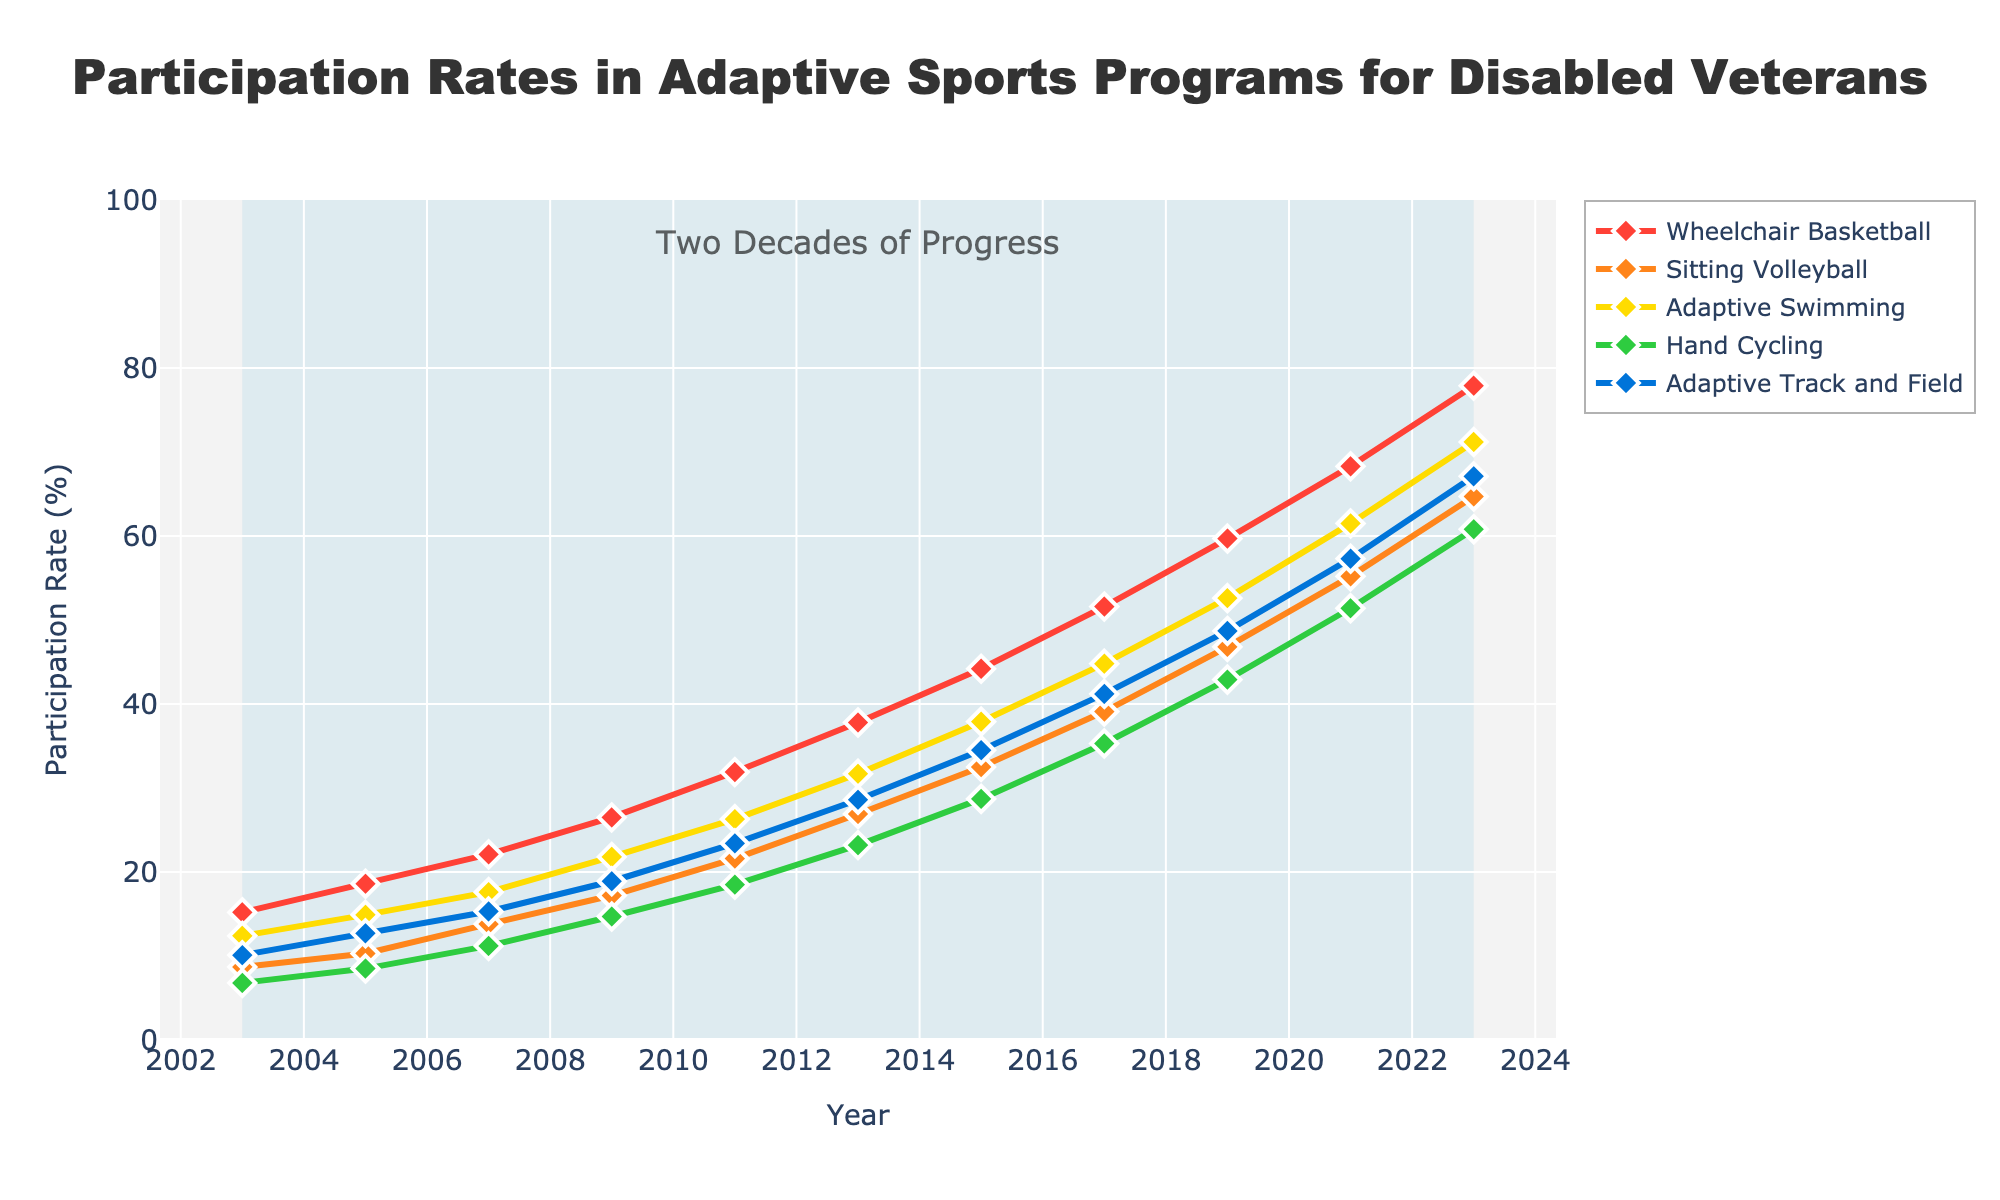Which adaptive sport had the highest participation rate in 2023? By visually inspecting the line chart, it can be seen that at the year 2023, "Wheelchair Basketball" reaches the highest point compared to other sports.
Answer: Wheelchair Basketball Which sport had the lowest initial participation rate in 2003? Looking at the beginning year 2003, "Hand Cycling" has the lowest starting point on the chart.
Answer: Hand Cycling What is the total increase in participation for Adaptive Swimming from 2003 to 2023? For 2003, Adaptive Swimming was at 12.4%. For 2023, it was at 71.2%. The increase is calculated as 71.2 - 12.4 = 58.8%.
Answer: 58.8% How does the participation rate of Sitting Volleyball in 2015 compare to that of Hand Cycling in 2011? For Sitting Volleyball in 2015, the rate was 32.5%. For Hand Cycling in 2011, the rate was 18.5%. Sitting Volleyball in 2015 had a higher participation rate.
Answer: Higher Between which consecutive years did Adaptive Track and Field see the greatest increase in participation rates? By examining the chart for Adaptive Track and Field, the most significant increase appears between 2019 (48.7%) and 2021 (57.3%). The difference is 57.3 - 48.7 = 8.6%.
Answer: 2019 to 2021 What was the average participation rate for Sitting Volleyball over the two decades? Adding the participation rates of Sitting Volleyball from 2003 to 2023 gives 8.7 + 10.3 + 13.8 + 17.2 + 21.6 + 26.9 + 32.5 + 39.1 + 46.8 + 55.2 + 64.7 = 336.8. Dividing by the number of years (11) gives 336.8 ÷ 11.
Answer: 30.6% Which sport showed a consistent trend without a decrease in participation rate over the years? Inspecting the trend lines for each sport, "Wheelchair Basketball" shows a consistent increase year after year without any decrease.
Answer: Wheelchair Basketball What is the difference in participation rates between the most and least popular sports in 2003? In 2003, the most popular sport was Wheelchair Basketball at 15.2%, and the least popular was Hand Cycling at 6.8%. The difference is 15.2 - 6.8 = 8.4%.
Answer: 8.4% By how much did the participation rate of Adaptive Track and Field increase from 2005 to 2015? In 2005, the rate was 12.7%, and in 2015 it was 34.5%. Hence, the increase is 34.5 - 12.7 = 21.8%.
Answer: 21.8% What was the average participation rate for Hand Cycling in the years 2017, 2019, and 2021? Summing the rates for Hand Cycling in these years gives 35.3 + 42.9 + 51.4 = 129.6. Dividing by 3 gives the average: 129.6 ÷ 3.
Answer: 43.2% 